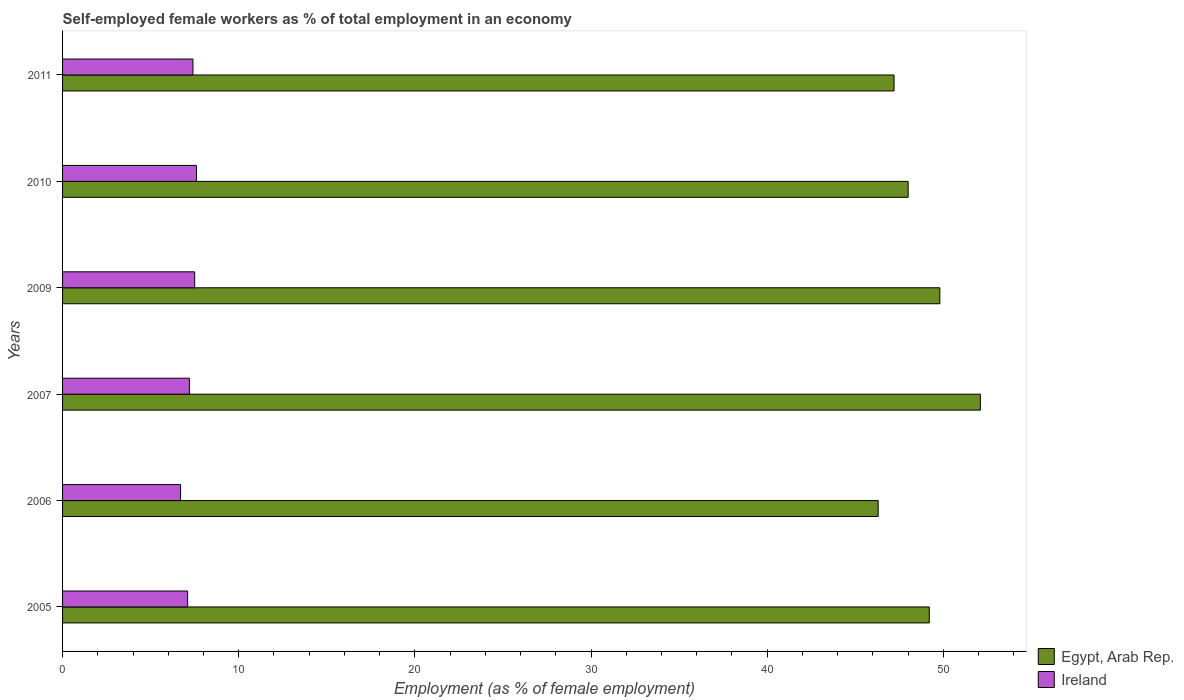How many different coloured bars are there?
Make the answer very short. 2. How many groups of bars are there?
Ensure brevity in your answer.  6. Are the number of bars per tick equal to the number of legend labels?
Keep it short and to the point. Yes. Are the number of bars on each tick of the Y-axis equal?
Give a very brief answer. Yes. What is the label of the 5th group of bars from the top?
Offer a terse response. 2006. What is the percentage of self-employed female workers in Egypt, Arab Rep. in 2007?
Your answer should be very brief. 52.1. Across all years, what is the maximum percentage of self-employed female workers in Ireland?
Give a very brief answer. 7.6. Across all years, what is the minimum percentage of self-employed female workers in Egypt, Arab Rep.?
Make the answer very short. 46.3. In which year was the percentage of self-employed female workers in Ireland maximum?
Ensure brevity in your answer.  2010. What is the total percentage of self-employed female workers in Ireland in the graph?
Your answer should be very brief. 43.5. What is the difference between the percentage of self-employed female workers in Egypt, Arab Rep. in 2005 and the percentage of self-employed female workers in Ireland in 2009?
Your answer should be compact. 41.7. What is the average percentage of self-employed female workers in Egypt, Arab Rep. per year?
Offer a very short reply. 48.77. In the year 2009, what is the difference between the percentage of self-employed female workers in Ireland and percentage of self-employed female workers in Egypt, Arab Rep.?
Ensure brevity in your answer.  -42.3. In how many years, is the percentage of self-employed female workers in Egypt, Arab Rep. greater than 14 %?
Keep it short and to the point. 6. What is the ratio of the percentage of self-employed female workers in Ireland in 2007 to that in 2011?
Your answer should be compact. 0.97. What is the difference between the highest and the second highest percentage of self-employed female workers in Egypt, Arab Rep.?
Provide a succinct answer. 2.3. What is the difference between the highest and the lowest percentage of self-employed female workers in Egypt, Arab Rep.?
Offer a terse response. 5.8. In how many years, is the percentage of self-employed female workers in Ireland greater than the average percentage of self-employed female workers in Ireland taken over all years?
Give a very brief answer. 3. What does the 1st bar from the top in 2011 represents?
Provide a succinct answer. Ireland. What does the 2nd bar from the bottom in 2010 represents?
Your response must be concise. Ireland. How many years are there in the graph?
Give a very brief answer. 6. Are the values on the major ticks of X-axis written in scientific E-notation?
Make the answer very short. No. Does the graph contain any zero values?
Keep it short and to the point. No. Does the graph contain grids?
Give a very brief answer. No. How are the legend labels stacked?
Your response must be concise. Vertical. What is the title of the graph?
Make the answer very short. Self-employed female workers as % of total employment in an economy. Does "Europe(developing only)" appear as one of the legend labels in the graph?
Make the answer very short. No. What is the label or title of the X-axis?
Your answer should be compact. Employment (as % of female employment). What is the label or title of the Y-axis?
Your response must be concise. Years. What is the Employment (as % of female employment) of Egypt, Arab Rep. in 2005?
Offer a terse response. 49.2. What is the Employment (as % of female employment) of Ireland in 2005?
Give a very brief answer. 7.1. What is the Employment (as % of female employment) of Egypt, Arab Rep. in 2006?
Your answer should be very brief. 46.3. What is the Employment (as % of female employment) of Ireland in 2006?
Your answer should be compact. 6.7. What is the Employment (as % of female employment) of Egypt, Arab Rep. in 2007?
Offer a very short reply. 52.1. What is the Employment (as % of female employment) of Ireland in 2007?
Make the answer very short. 7.2. What is the Employment (as % of female employment) in Egypt, Arab Rep. in 2009?
Your response must be concise. 49.8. What is the Employment (as % of female employment) of Egypt, Arab Rep. in 2010?
Give a very brief answer. 48. What is the Employment (as % of female employment) in Ireland in 2010?
Make the answer very short. 7.6. What is the Employment (as % of female employment) of Egypt, Arab Rep. in 2011?
Offer a terse response. 47.2. What is the Employment (as % of female employment) of Ireland in 2011?
Ensure brevity in your answer.  7.4. Across all years, what is the maximum Employment (as % of female employment) in Egypt, Arab Rep.?
Make the answer very short. 52.1. Across all years, what is the maximum Employment (as % of female employment) of Ireland?
Offer a terse response. 7.6. Across all years, what is the minimum Employment (as % of female employment) in Egypt, Arab Rep.?
Offer a very short reply. 46.3. Across all years, what is the minimum Employment (as % of female employment) in Ireland?
Your answer should be very brief. 6.7. What is the total Employment (as % of female employment) in Egypt, Arab Rep. in the graph?
Keep it short and to the point. 292.6. What is the total Employment (as % of female employment) of Ireland in the graph?
Your answer should be very brief. 43.5. What is the difference between the Employment (as % of female employment) in Egypt, Arab Rep. in 2005 and that in 2006?
Your answer should be compact. 2.9. What is the difference between the Employment (as % of female employment) in Ireland in 2005 and that in 2006?
Keep it short and to the point. 0.4. What is the difference between the Employment (as % of female employment) in Egypt, Arab Rep. in 2005 and that in 2009?
Make the answer very short. -0.6. What is the difference between the Employment (as % of female employment) of Ireland in 2005 and that in 2010?
Give a very brief answer. -0.5. What is the difference between the Employment (as % of female employment) of Egypt, Arab Rep. in 2005 and that in 2011?
Make the answer very short. 2. What is the difference between the Employment (as % of female employment) of Ireland in 2005 and that in 2011?
Give a very brief answer. -0.3. What is the difference between the Employment (as % of female employment) in Egypt, Arab Rep. in 2006 and that in 2007?
Ensure brevity in your answer.  -5.8. What is the difference between the Employment (as % of female employment) of Ireland in 2006 and that in 2007?
Provide a succinct answer. -0.5. What is the difference between the Employment (as % of female employment) in Ireland in 2006 and that in 2011?
Offer a very short reply. -0.7. What is the difference between the Employment (as % of female employment) in Ireland in 2007 and that in 2009?
Your answer should be compact. -0.3. What is the difference between the Employment (as % of female employment) in Ireland in 2007 and that in 2011?
Your response must be concise. -0.2. What is the difference between the Employment (as % of female employment) of Egypt, Arab Rep. in 2009 and that in 2010?
Keep it short and to the point. 1.8. What is the difference between the Employment (as % of female employment) of Egypt, Arab Rep. in 2009 and that in 2011?
Offer a terse response. 2.6. What is the difference between the Employment (as % of female employment) in Egypt, Arab Rep. in 2010 and that in 2011?
Your response must be concise. 0.8. What is the difference between the Employment (as % of female employment) in Ireland in 2010 and that in 2011?
Provide a succinct answer. 0.2. What is the difference between the Employment (as % of female employment) of Egypt, Arab Rep. in 2005 and the Employment (as % of female employment) of Ireland in 2006?
Provide a succinct answer. 42.5. What is the difference between the Employment (as % of female employment) of Egypt, Arab Rep. in 2005 and the Employment (as % of female employment) of Ireland in 2009?
Offer a very short reply. 41.7. What is the difference between the Employment (as % of female employment) in Egypt, Arab Rep. in 2005 and the Employment (as % of female employment) in Ireland in 2010?
Provide a succinct answer. 41.6. What is the difference between the Employment (as % of female employment) in Egypt, Arab Rep. in 2005 and the Employment (as % of female employment) in Ireland in 2011?
Ensure brevity in your answer.  41.8. What is the difference between the Employment (as % of female employment) of Egypt, Arab Rep. in 2006 and the Employment (as % of female employment) of Ireland in 2007?
Your answer should be very brief. 39.1. What is the difference between the Employment (as % of female employment) of Egypt, Arab Rep. in 2006 and the Employment (as % of female employment) of Ireland in 2009?
Ensure brevity in your answer.  38.8. What is the difference between the Employment (as % of female employment) of Egypt, Arab Rep. in 2006 and the Employment (as % of female employment) of Ireland in 2010?
Ensure brevity in your answer.  38.7. What is the difference between the Employment (as % of female employment) in Egypt, Arab Rep. in 2006 and the Employment (as % of female employment) in Ireland in 2011?
Your answer should be compact. 38.9. What is the difference between the Employment (as % of female employment) of Egypt, Arab Rep. in 2007 and the Employment (as % of female employment) of Ireland in 2009?
Offer a very short reply. 44.6. What is the difference between the Employment (as % of female employment) of Egypt, Arab Rep. in 2007 and the Employment (as % of female employment) of Ireland in 2010?
Make the answer very short. 44.5. What is the difference between the Employment (as % of female employment) of Egypt, Arab Rep. in 2007 and the Employment (as % of female employment) of Ireland in 2011?
Make the answer very short. 44.7. What is the difference between the Employment (as % of female employment) in Egypt, Arab Rep. in 2009 and the Employment (as % of female employment) in Ireland in 2010?
Ensure brevity in your answer.  42.2. What is the difference between the Employment (as % of female employment) in Egypt, Arab Rep. in 2009 and the Employment (as % of female employment) in Ireland in 2011?
Give a very brief answer. 42.4. What is the difference between the Employment (as % of female employment) of Egypt, Arab Rep. in 2010 and the Employment (as % of female employment) of Ireland in 2011?
Offer a very short reply. 40.6. What is the average Employment (as % of female employment) in Egypt, Arab Rep. per year?
Your response must be concise. 48.77. What is the average Employment (as % of female employment) of Ireland per year?
Ensure brevity in your answer.  7.25. In the year 2005, what is the difference between the Employment (as % of female employment) in Egypt, Arab Rep. and Employment (as % of female employment) in Ireland?
Provide a short and direct response. 42.1. In the year 2006, what is the difference between the Employment (as % of female employment) of Egypt, Arab Rep. and Employment (as % of female employment) of Ireland?
Give a very brief answer. 39.6. In the year 2007, what is the difference between the Employment (as % of female employment) of Egypt, Arab Rep. and Employment (as % of female employment) of Ireland?
Your response must be concise. 44.9. In the year 2009, what is the difference between the Employment (as % of female employment) in Egypt, Arab Rep. and Employment (as % of female employment) in Ireland?
Make the answer very short. 42.3. In the year 2010, what is the difference between the Employment (as % of female employment) in Egypt, Arab Rep. and Employment (as % of female employment) in Ireland?
Your answer should be compact. 40.4. In the year 2011, what is the difference between the Employment (as % of female employment) in Egypt, Arab Rep. and Employment (as % of female employment) in Ireland?
Provide a succinct answer. 39.8. What is the ratio of the Employment (as % of female employment) of Egypt, Arab Rep. in 2005 to that in 2006?
Offer a very short reply. 1.06. What is the ratio of the Employment (as % of female employment) of Ireland in 2005 to that in 2006?
Your answer should be very brief. 1.06. What is the ratio of the Employment (as % of female employment) of Egypt, Arab Rep. in 2005 to that in 2007?
Give a very brief answer. 0.94. What is the ratio of the Employment (as % of female employment) of Ireland in 2005 to that in 2007?
Provide a succinct answer. 0.99. What is the ratio of the Employment (as % of female employment) of Egypt, Arab Rep. in 2005 to that in 2009?
Give a very brief answer. 0.99. What is the ratio of the Employment (as % of female employment) in Ireland in 2005 to that in 2009?
Ensure brevity in your answer.  0.95. What is the ratio of the Employment (as % of female employment) of Ireland in 2005 to that in 2010?
Provide a succinct answer. 0.93. What is the ratio of the Employment (as % of female employment) in Egypt, Arab Rep. in 2005 to that in 2011?
Make the answer very short. 1.04. What is the ratio of the Employment (as % of female employment) of Ireland in 2005 to that in 2011?
Keep it short and to the point. 0.96. What is the ratio of the Employment (as % of female employment) of Egypt, Arab Rep. in 2006 to that in 2007?
Your response must be concise. 0.89. What is the ratio of the Employment (as % of female employment) in Ireland in 2006 to that in 2007?
Ensure brevity in your answer.  0.93. What is the ratio of the Employment (as % of female employment) in Egypt, Arab Rep. in 2006 to that in 2009?
Your answer should be compact. 0.93. What is the ratio of the Employment (as % of female employment) in Ireland in 2006 to that in 2009?
Offer a terse response. 0.89. What is the ratio of the Employment (as % of female employment) in Egypt, Arab Rep. in 2006 to that in 2010?
Provide a succinct answer. 0.96. What is the ratio of the Employment (as % of female employment) of Ireland in 2006 to that in 2010?
Your response must be concise. 0.88. What is the ratio of the Employment (as % of female employment) of Egypt, Arab Rep. in 2006 to that in 2011?
Your answer should be compact. 0.98. What is the ratio of the Employment (as % of female employment) of Ireland in 2006 to that in 2011?
Offer a terse response. 0.91. What is the ratio of the Employment (as % of female employment) in Egypt, Arab Rep. in 2007 to that in 2009?
Your answer should be very brief. 1.05. What is the ratio of the Employment (as % of female employment) of Ireland in 2007 to that in 2009?
Your answer should be compact. 0.96. What is the ratio of the Employment (as % of female employment) in Egypt, Arab Rep. in 2007 to that in 2010?
Give a very brief answer. 1.09. What is the ratio of the Employment (as % of female employment) in Egypt, Arab Rep. in 2007 to that in 2011?
Your answer should be compact. 1.1. What is the ratio of the Employment (as % of female employment) of Ireland in 2007 to that in 2011?
Offer a terse response. 0.97. What is the ratio of the Employment (as % of female employment) of Egypt, Arab Rep. in 2009 to that in 2010?
Offer a terse response. 1.04. What is the ratio of the Employment (as % of female employment) of Ireland in 2009 to that in 2010?
Offer a terse response. 0.99. What is the ratio of the Employment (as % of female employment) in Egypt, Arab Rep. in 2009 to that in 2011?
Give a very brief answer. 1.06. What is the ratio of the Employment (as % of female employment) of Ireland in 2009 to that in 2011?
Offer a terse response. 1.01. What is the ratio of the Employment (as % of female employment) in Egypt, Arab Rep. in 2010 to that in 2011?
Your answer should be very brief. 1.02. What is the ratio of the Employment (as % of female employment) of Ireland in 2010 to that in 2011?
Your answer should be very brief. 1.03. What is the difference between the highest and the second highest Employment (as % of female employment) in Egypt, Arab Rep.?
Your answer should be very brief. 2.3. What is the difference between the highest and the lowest Employment (as % of female employment) of Egypt, Arab Rep.?
Give a very brief answer. 5.8. 